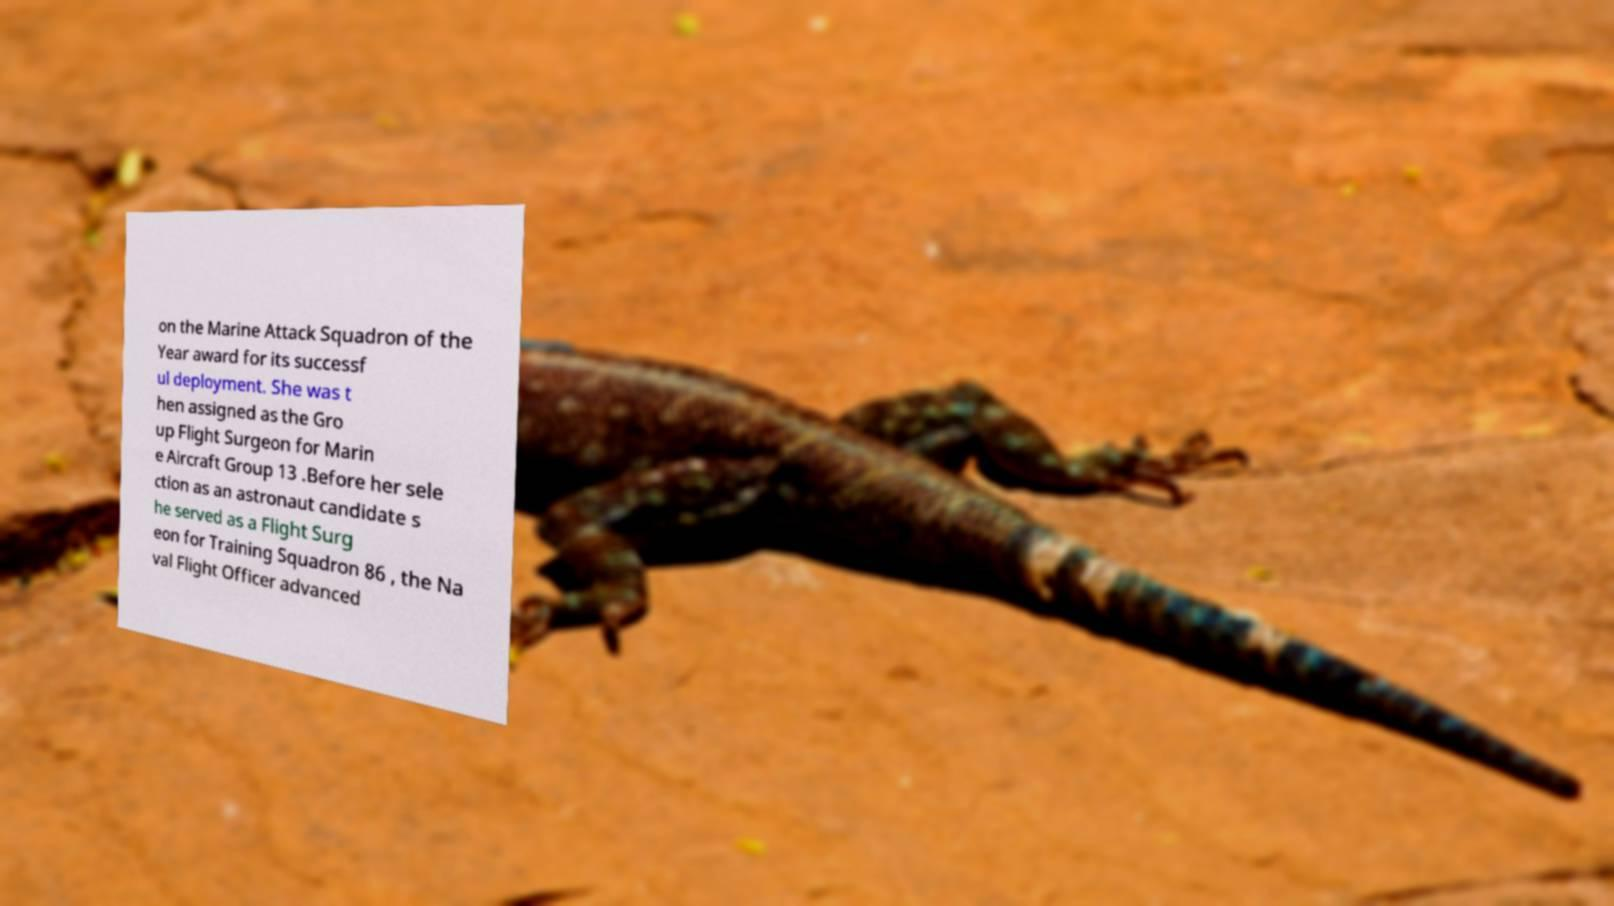Can you read and provide the text displayed in the image?This photo seems to have some interesting text. Can you extract and type it out for me? on the Marine Attack Squadron of the Year award for its successf ul deployment. She was t hen assigned as the Gro up Flight Surgeon for Marin e Aircraft Group 13 .Before her sele ction as an astronaut candidate s he served as a Flight Surg eon for Training Squadron 86 , the Na val Flight Officer advanced 